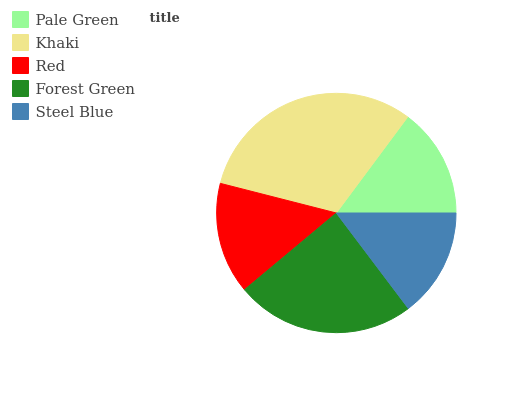Is Steel Blue the minimum?
Answer yes or no. Yes. Is Khaki the maximum?
Answer yes or no. Yes. Is Red the minimum?
Answer yes or no. No. Is Red the maximum?
Answer yes or no. No. Is Khaki greater than Red?
Answer yes or no. Yes. Is Red less than Khaki?
Answer yes or no. Yes. Is Red greater than Khaki?
Answer yes or no. No. Is Khaki less than Red?
Answer yes or no. No. Is Red the high median?
Answer yes or no. Yes. Is Red the low median?
Answer yes or no. Yes. Is Steel Blue the high median?
Answer yes or no. No. Is Steel Blue the low median?
Answer yes or no. No. 